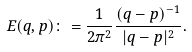Convert formula to latex. <formula><loc_0><loc_0><loc_500><loc_500>E ( q , p ) \colon = \frac { 1 } { 2 \pi ^ { 2 } } \frac { ( q - p ) ^ { - 1 } } { | q - p | ^ { 2 } } .</formula> 